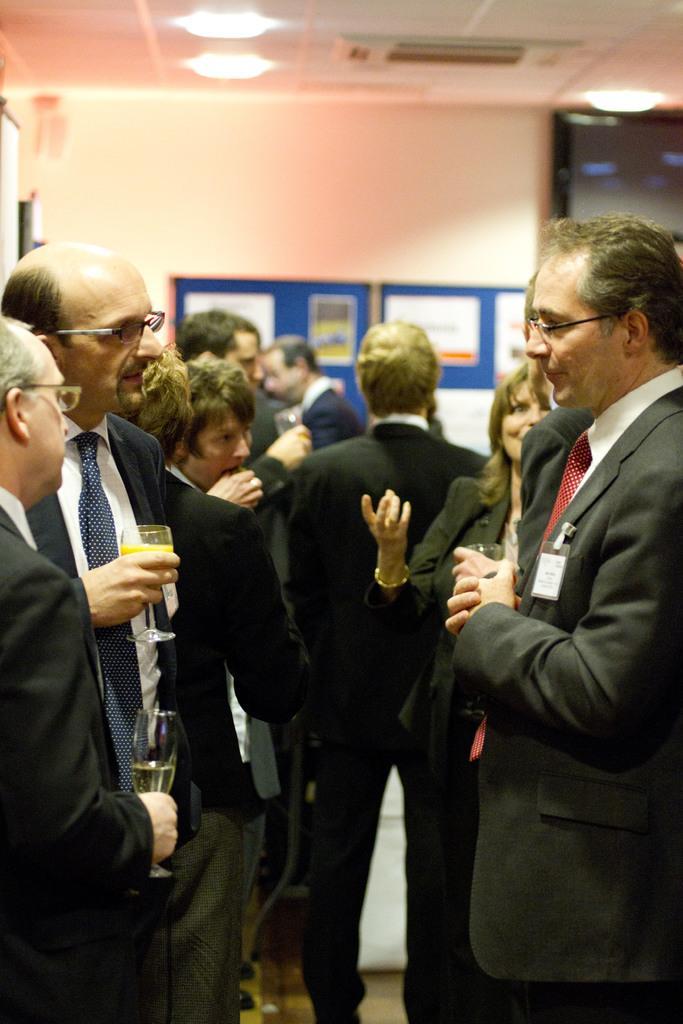Can you describe this image briefly? In this image in front there are people standing on the floor. Behind them there is a board with posters on it which is attached to the wall. On top of the image there are lights. 